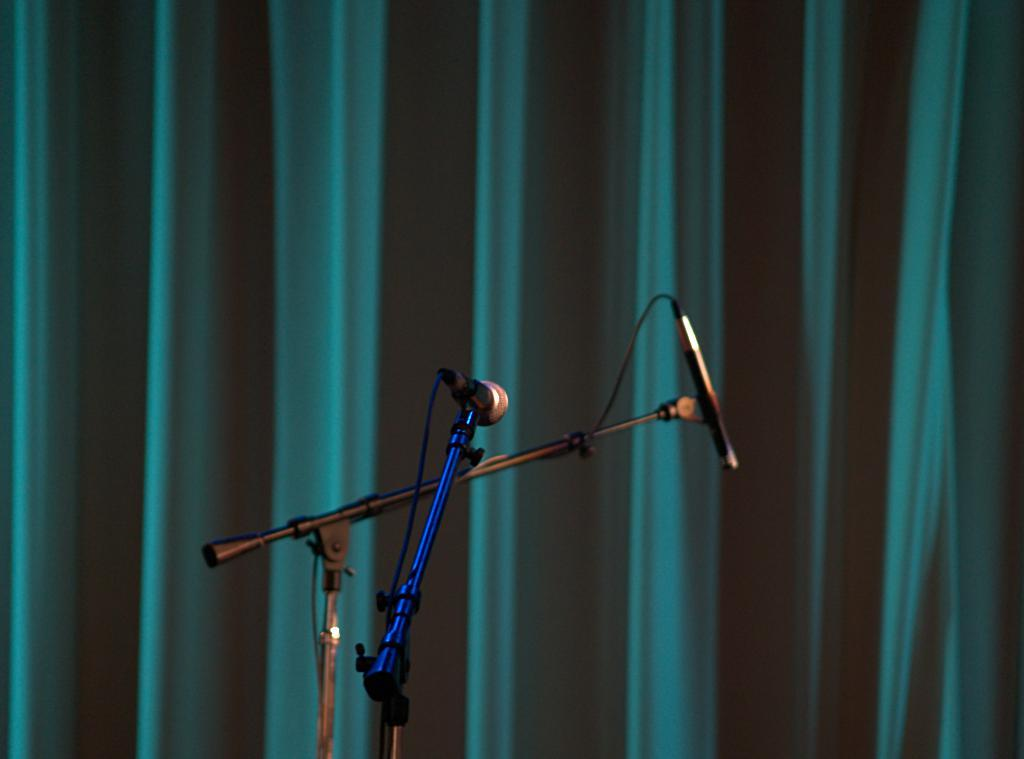How many microphones are visible in the image? There are two microphones in the image. What are the microphones connected to? The microphones have wires. How are the microphones positioned in the image? The microphones have stands. What can be seen in the background of the image? There is an object in the background that looks like a curtain. How many partners are visible in the image? There are no partners visible in the image; it only features microphones and a curtain. What is the fifth object in the image? There is no fifth object in the image; there are only two microphones, their wires, stands, and the curtain. 